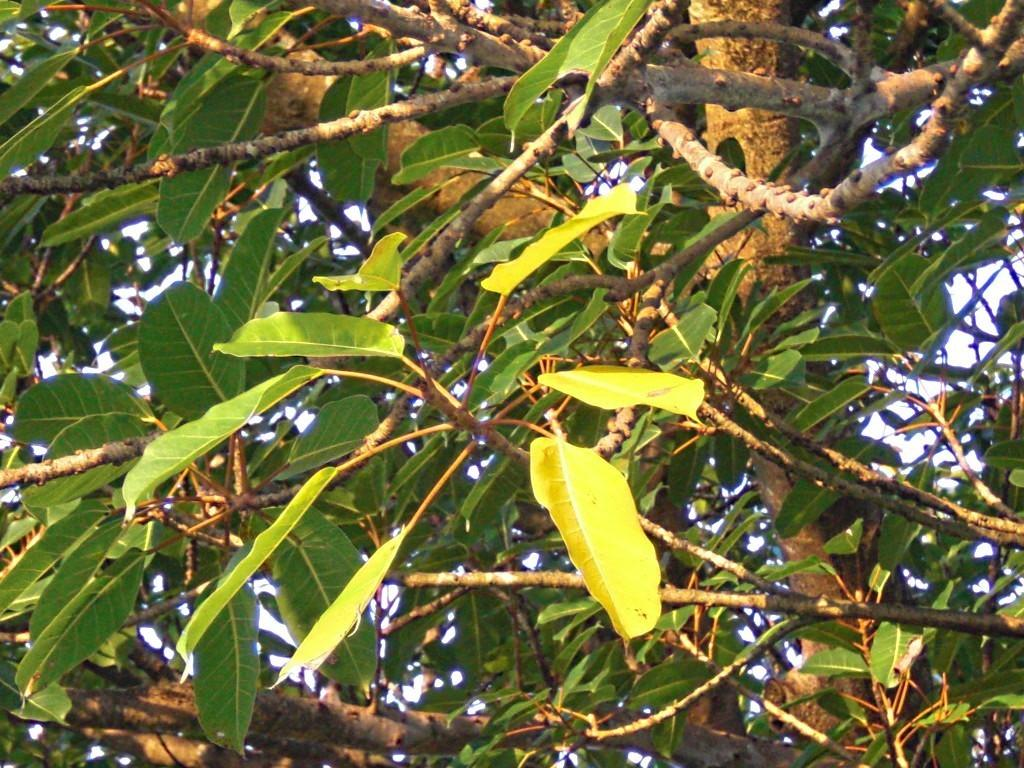What type of vegetation can be seen in the image? There are trees in the image. What is visible behind the trees in the image? The sky is visible behind the trees in the image. What role does the actor play in the image? There is no actor present in the image; it features trees and the sky. Can you tell me which door leads to the location depicted in the image? There is no door present in the image, as it only features trees and the sky. 